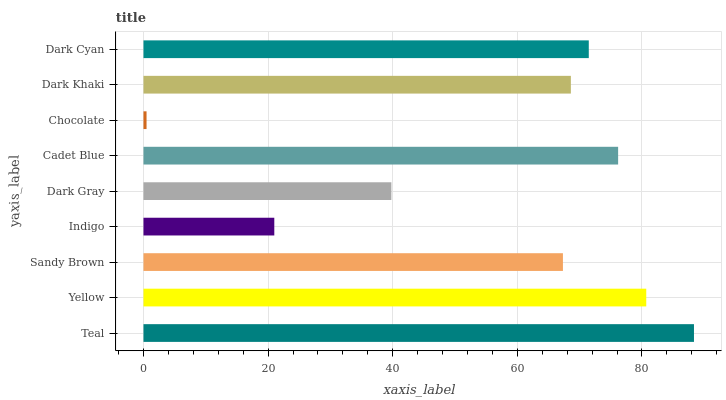Is Chocolate the minimum?
Answer yes or no. Yes. Is Teal the maximum?
Answer yes or no. Yes. Is Yellow the minimum?
Answer yes or no. No. Is Yellow the maximum?
Answer yes or no. No. Is Teal greater than Yellow?
Answer yes or no. Yes. Is Yellow less than Teal?
Answer yes or no. Yes. Is Yellow greater than Teal?
Answer yes or no. No. Is Teal less than Yellow?
Answer yes or no. No. Is Dark Khaki the high median?
Answer yes or no. Yes. Is Dark Khaki the low median?
Answer yes or no. Yes. Is Indigo the high median?
Answer yes or no. No. Is Yellow the low median?
Answer yes or no. No. 